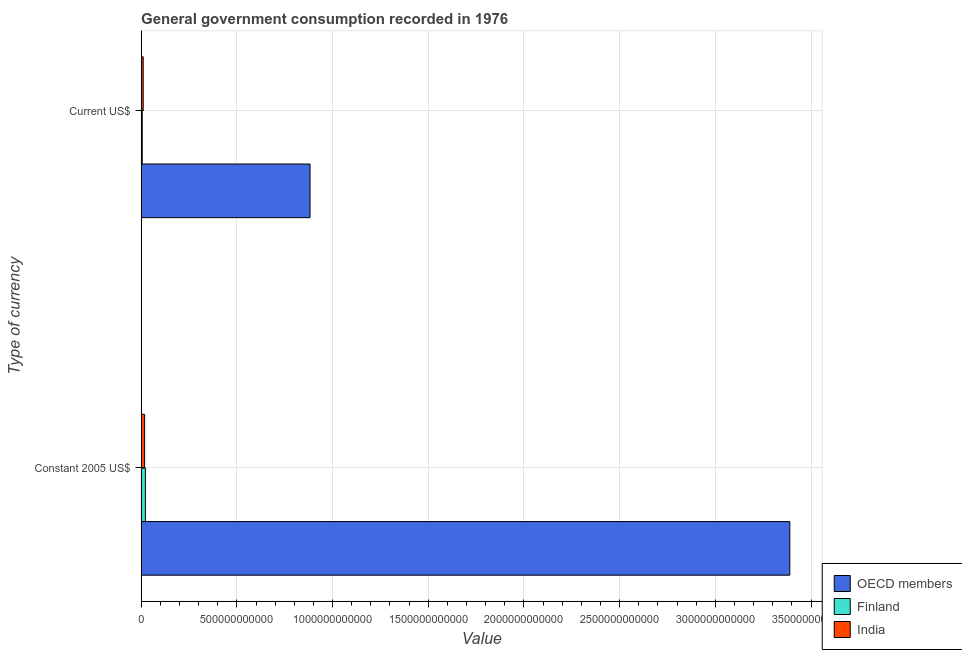How many different coloured bars are there?
Offer a terse response. 3. Are the number of bars per tick equal to the number of legend labels?
Provide a short and direct response. Yes. How many bars are there on the 2nd tick from the bottom?
Provide a succinct answer. 3. What is the label of the 1st group of bars from the top?
Give a very brief answer. Current US$. What is the value consumed in constant 2005 us$ in Finland?
Your response must be concise. 2.22e+1. Across all countries, what is the maximum value consumed in current us$?
Your response must be concise. 8.82e+11. Across all countries, what is the minimum value consumed in constant 2005 us$?
Make the answer very short. 1.81e+1. In which country was the value consumed in current us$ minimum?
Give a very brief answer. Finland. What is the total value consumed in current us$ in the graph?
Your answer should be very brief. 8.99e+11. What is the difference between the value consumed in current us$ in OECD members and that in India?
Make the answer very short. 8.72e+11. What is the difference between the value consumed in constant 2005 us$ in OECD members and the value consumed in current us$ in India?
Provide a succinct answer. 3.38e+12. What is the average value consumed in constant 2005 us$ per country?
Your answer should be very brief. 1.14e+12. What is the difference between the value consumed in constant 2005 us$ and value consumed in current us$ in Finland?
Your response must be concise. 1.64e+1. What is the ratio of the value consumed in current us$ in Finland to that in India?
Your answer should be compact. 0.53. In how many countries, is the value consumed in current us$ greater than the average value consumed in current us$ taken over all countries?
Provide a succinct answer. 1. How many bars are there?
Keep it short and to the point. 6. What is the difference between two consecutive major ticks on the X-axis?
Your response must be concise. 5.00e+11. How many legend labels are there?
Keep it short and to the point. 3. What is the title of the graph?
Make the answer very short. General government consumption recorded in 1976. What is the label or title of the X-axis?
Provide a succinct answer. Value. What is the label or title of the Y-axis?
Provide a short and direct response. Type of currency. What is the Value in OECD members in Constant 2005 US$?
Give a very brief answer. 3.39e+12. What is the Value of Finland in Constant 2005 US$?
Provide a short and direct response. 2.22e+1. What is the Value in India in Constant 2005 US$?
Make the answer very short. 1.81e+1. What is the Value in OECD members in Current US$?
Make the answer very short. 8.82e+11. What is the Value in Finland in Current US$?
Offer a very short reply. 5.71e+09. What is the Value in India in Current US$?
Keep it short and to the point. 1.07e+1. Across all Type of currency, what is the maximum Value of OECD members?
Your answer should be very brief. 3.39e+12. Across all Type of currency, what is the maximum Value in Finland?
Your answer should be very brief. 2.22e+1. Across all Type of currency, what is the maximum Value in India?
Offer a terse response. 1.81e+1. Across all Type of currency, what is the minimum Value in OECD members?
Provide a succinct answer. 8.82e+11. Across all Type of currency, what is the minimum Value in Finland?
Offer a terse response. 5.71e+09. Across all Type of currency, what is the minimum Value in India?
Your response must be concise. 1.07e+1. What is the total Value of OECD members in the graph?
Make the answer very short. 4.27e+12. What is the total Value of Finland in the graph?
Your answer should be very brief. 2.79e+1. What is the total Value in India in the graph?
Give a very brief answer. 2.89e+1. What is the difference between the Value in OECD members in Constant 2005 US$ and that in Current US$?
Keep it short and to the point. 2.51e+12. What is the difference between the Value in Finland in Constant 2005 US$ and that in Current US$?
Provide a succinct answer. 1.64e+1. What is the difference between the Value in India in Constant 2005 US$ and that in Current US$?
Keep it short and to the point. 7.37e+09. What is the difference between the Value in OECD members in Constant 2005 US$ and the Value in Finland in Current US$?
Provide a short and direct response. 3.38e+12. What is the difference between the Value in OECD members in Constant 2005 US$ and the Value in India in Current US$?
Give a very brief answer. 3.38e+12. What is the difference between the Value in Finland in Constant 2005 US$ and the Value in India in Current US$?
Your answer should be compact. 1.14e+1. What is the average Value of OECD members per Type of currency?
Provide a succinct answer. 2.14e+12. What is the average Value in Finland per Type of currency?
Give a very brief answer. 1.39e+1. What is the average Value in India per Type of currency?
Your answer should be very brief. 1.44e+1. What is the difference between the Value of OECD members and Value of Finland in Constant 2005 US$?
Provide a short and direct response. 3.37e+12. What is the difference between the Value in OECD members and Value in India in Constant 2005 US$?
Your response must be concise. 3.37e+12. What is the difference between the Value of Finland and Value of India in Constant 2005 US$?
Give a very brief answer. 4.04e+09. What is the difference between the Value of OECD members and Value of Finland in Current US$?
Your answer should be very brief. 8.77e+11. What is the difference between the Value of OECD members and Value of India in Current US$?
Your answer should be very brief. 8.72e+11. What is the difference between the Value in Finland and Value in India in Current US$?
Your response must be concise. -5.03e+09. What is the ratio of the Value of OECD members in Constant 2005 US$ to that in Current US$?
Your response must be concise. 3.84. What is the ratio of the Value of Finland in Constant 2005 US$ to that in Current US$?
Provide a succinct answer. 3.88. What is the ratio of the Value of India in Constant 2005 US$ to that in Current US$?
Provide a succinct answer. 1.69. What is the difference between the highest and the second highest Value in OECD members?
Ensure brevity in your answer.  2.51e+12. What is the difference between the highest and the second highest Value in Finland?
Your answer should be very brief. 1.64e+1. What is the difference between the highest and the second highest Value in India?
Make the answer very short. 7.37e+09. What is the difference between the highest and the lowest Value of OECD members?
Offer a very short reply. 2.51e+12. What is the difference between the highest and the lowest Value of Finland?
Provide a succinct answer. 1.64e+1. What is the difference between the highest and the lowest Value of India?
Give a very brief answer. 7.37e+09. 